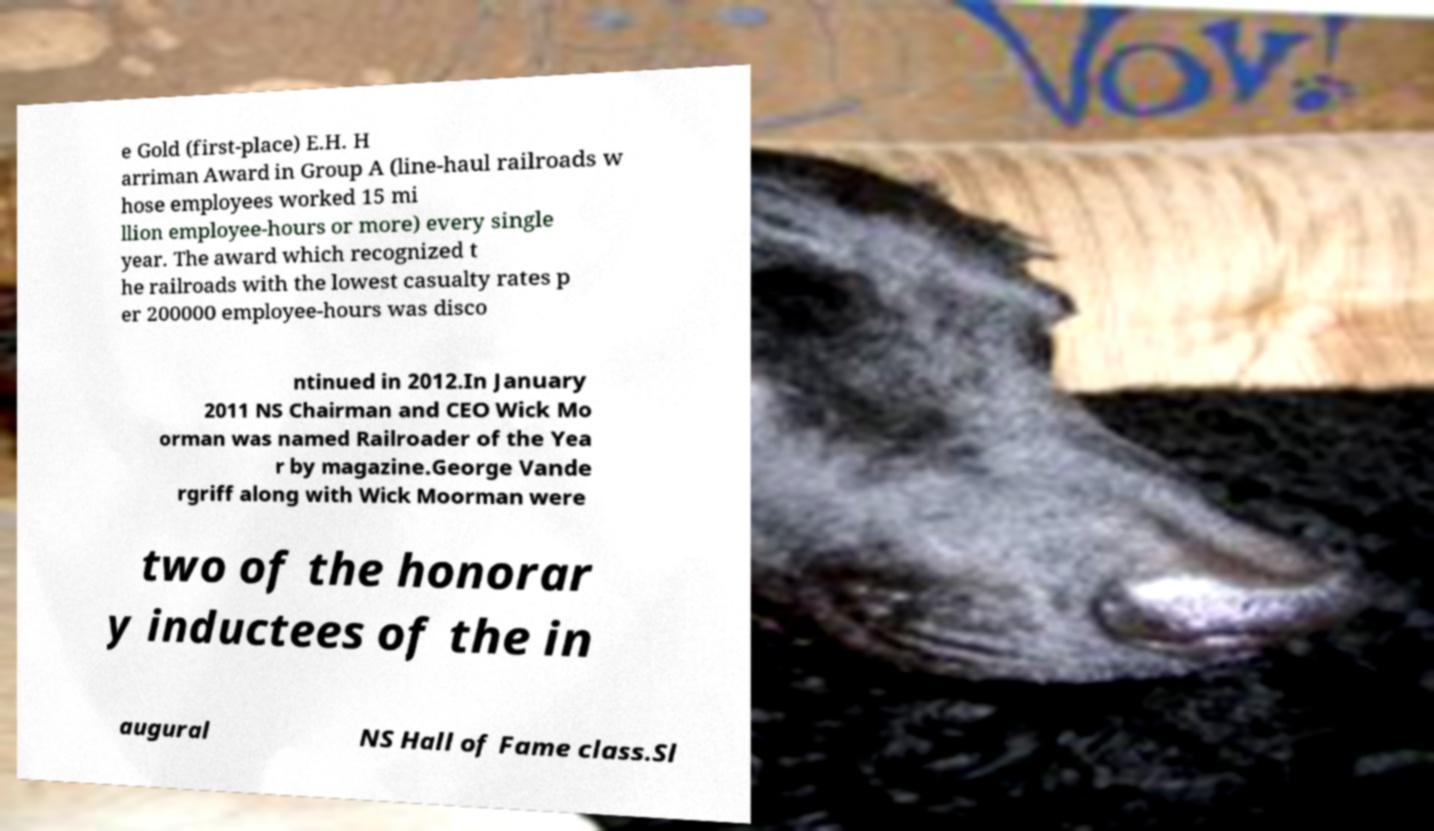I need the written content from this picture converted into text. Can you do that? e Gold (first-place) E.H. H arriman Award in Group A (line-haul railroads w hose employees worked 15 mi llion employee-hours or more) every single year. The award which recognized t he railroads with the lowest casualty rates p er 200000 employee-hours was disco ntinued in 2012.In January 2011 NS Chairman and CEO Wick Mo orman was named Railroader of the Yea r by magazine.George Vande rgriff along with Wick Moorman were two of the honorar y inductees of the in augural NS Hall of Fame class.Sl 